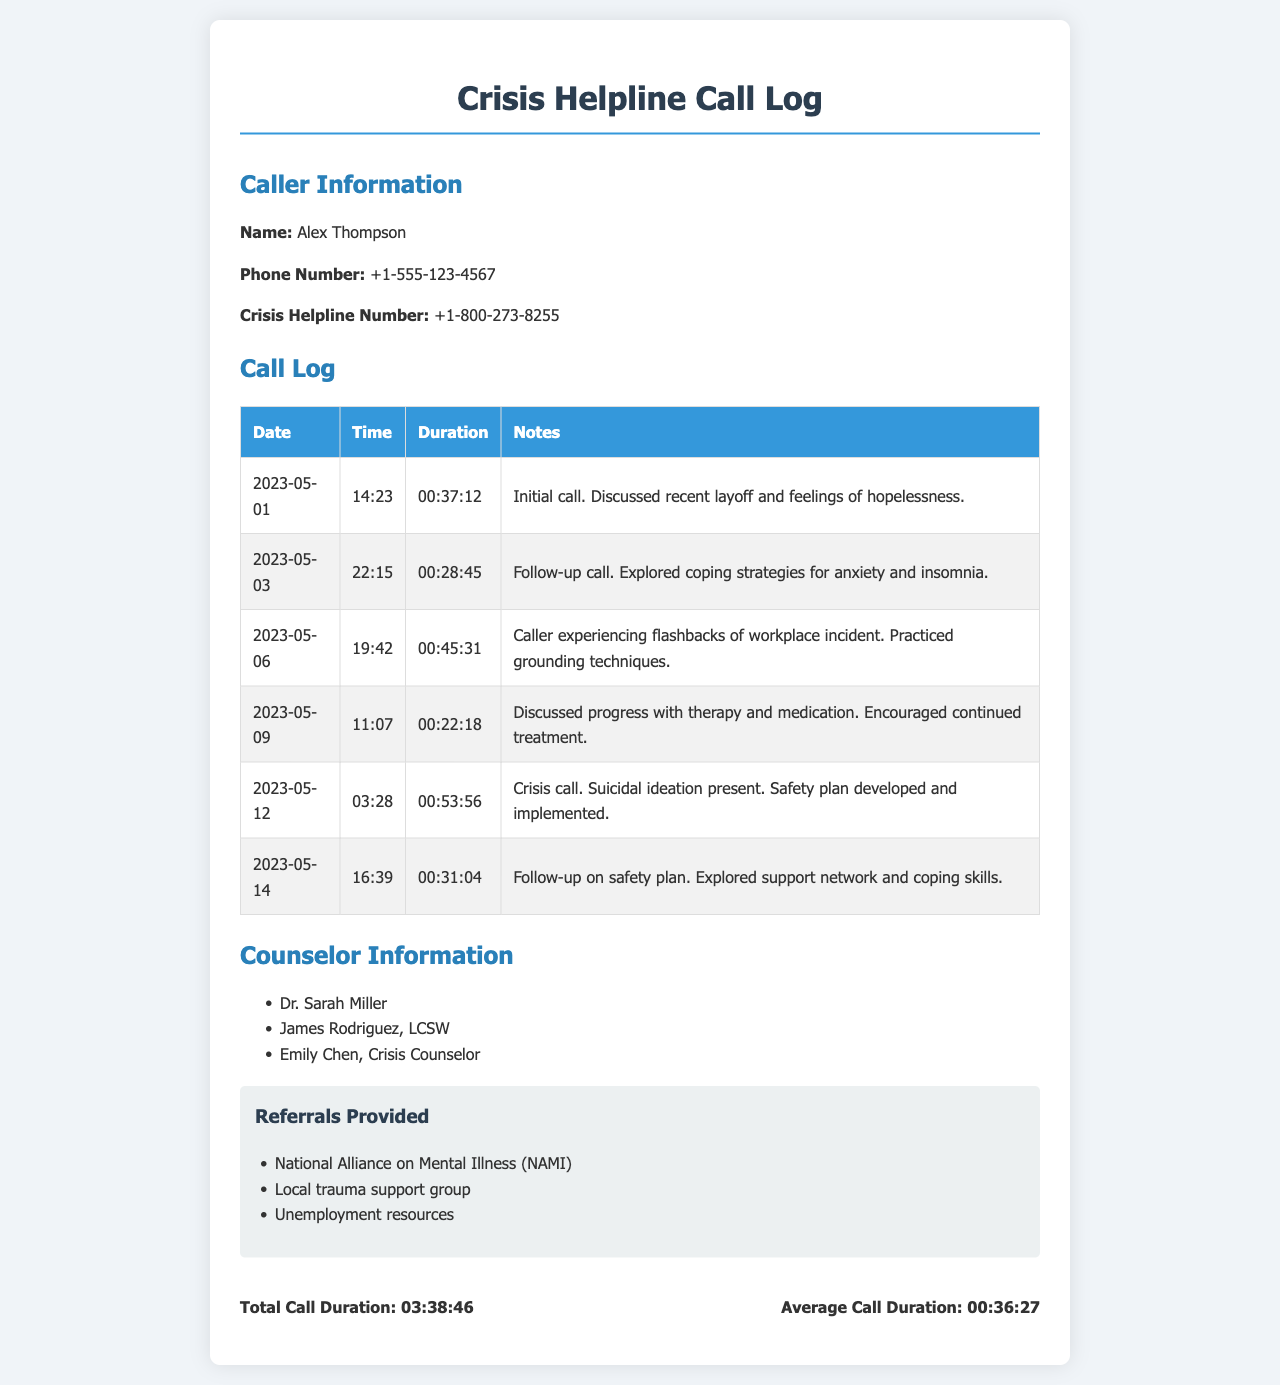What is the name of the caller? The document provides the name of the caller in the information section, which is Alex Thompson.
Answer: Alex Thompson How many total calls did the caller make? The call log shows a total of six entries, indicating the number of calls made by the caller.
Answer: 6 What was the duration of the first call? The call log specifies the duration of the first call, which is recorded as 00:37:12.
Answer: 00:37:12 What date was the crisis call made? The crisis call is highlighted in the log and occurred on 2023-05-12.
Answer: 2023-05-12 Who provided the last follow-up? The call log indicates the last follow-up was on 2023-05-14, but does not specify a counselor for that call.
Answer: Not specified What is the average call duration? The summary section calculates the average call duration based on total call time divided by number of calls, which is mentioned as 00:36:27.
Answer: 00:36:27 Which crisis helpline number is listed? The document includes the helpline number in the caller information section, which is +1-800-273-8255.
Answer: +1-800-273-8255 What type of referrals were provided? The document lists referrals in a section specifically for that purpose, including "National Alliance on Mental Illness (NAMI)" and others.
Answer: National Alliance on Mental Illness, Local trauma support group, Unemployment resources What emotions were discussed during the initial call? The notes for the initial call mention feelings of hopelessness as a key emotional topic.
Answer: Feelings of hopelessness Which counselor was not mentioned in the context of follow-ups? The counselor information includes three names, but only provide notes on specific follow-ups for Dr. Sarah Miller and James Rodriguez.
Answer: Emily Chen 